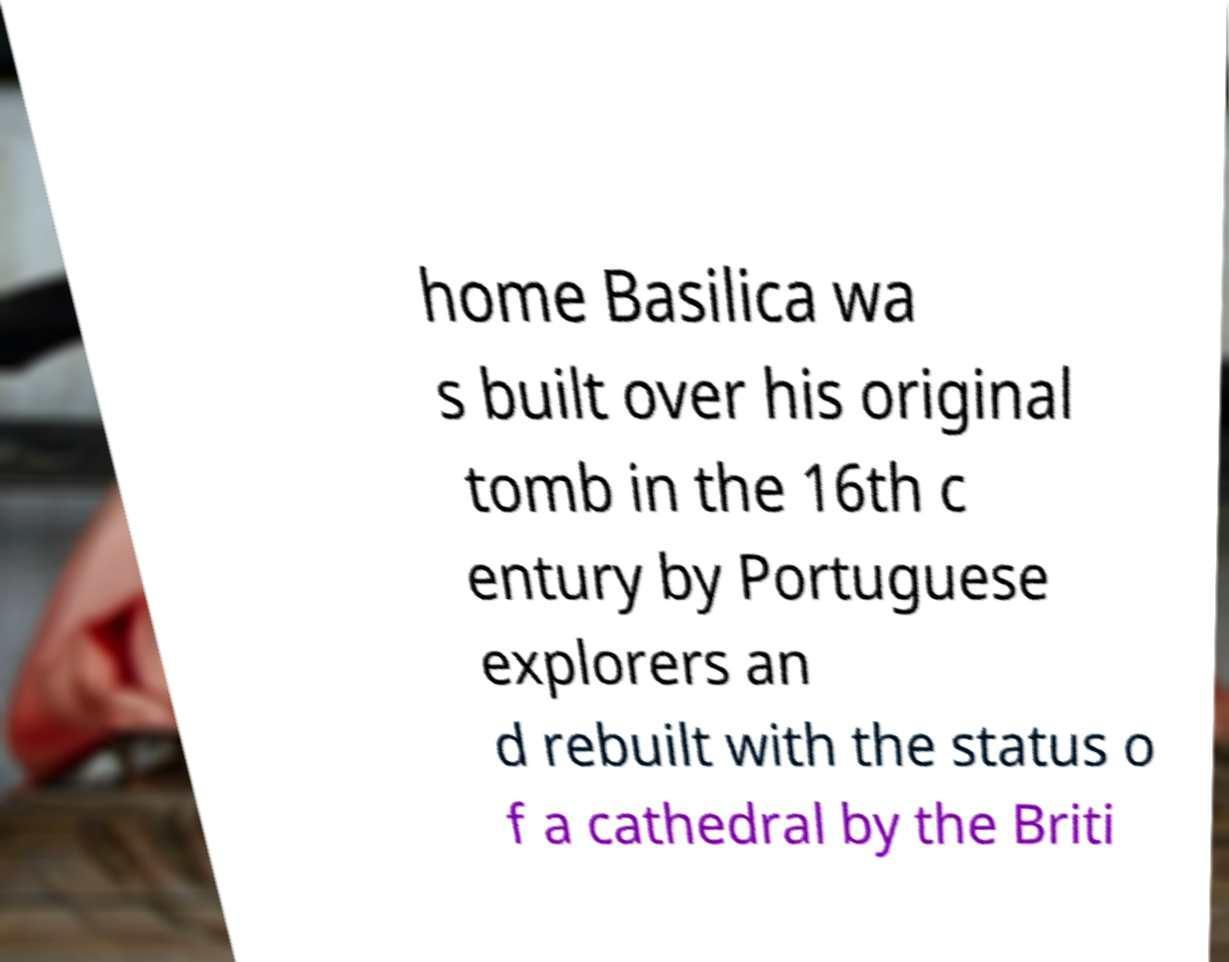Could you assist in decoding the text presented in this image and type it out clearly? home Basilica wa s built over his original tomb in the 16th c entury by Portuguese explorers an d rebuilt with the status o f a cathedral by the Briti 